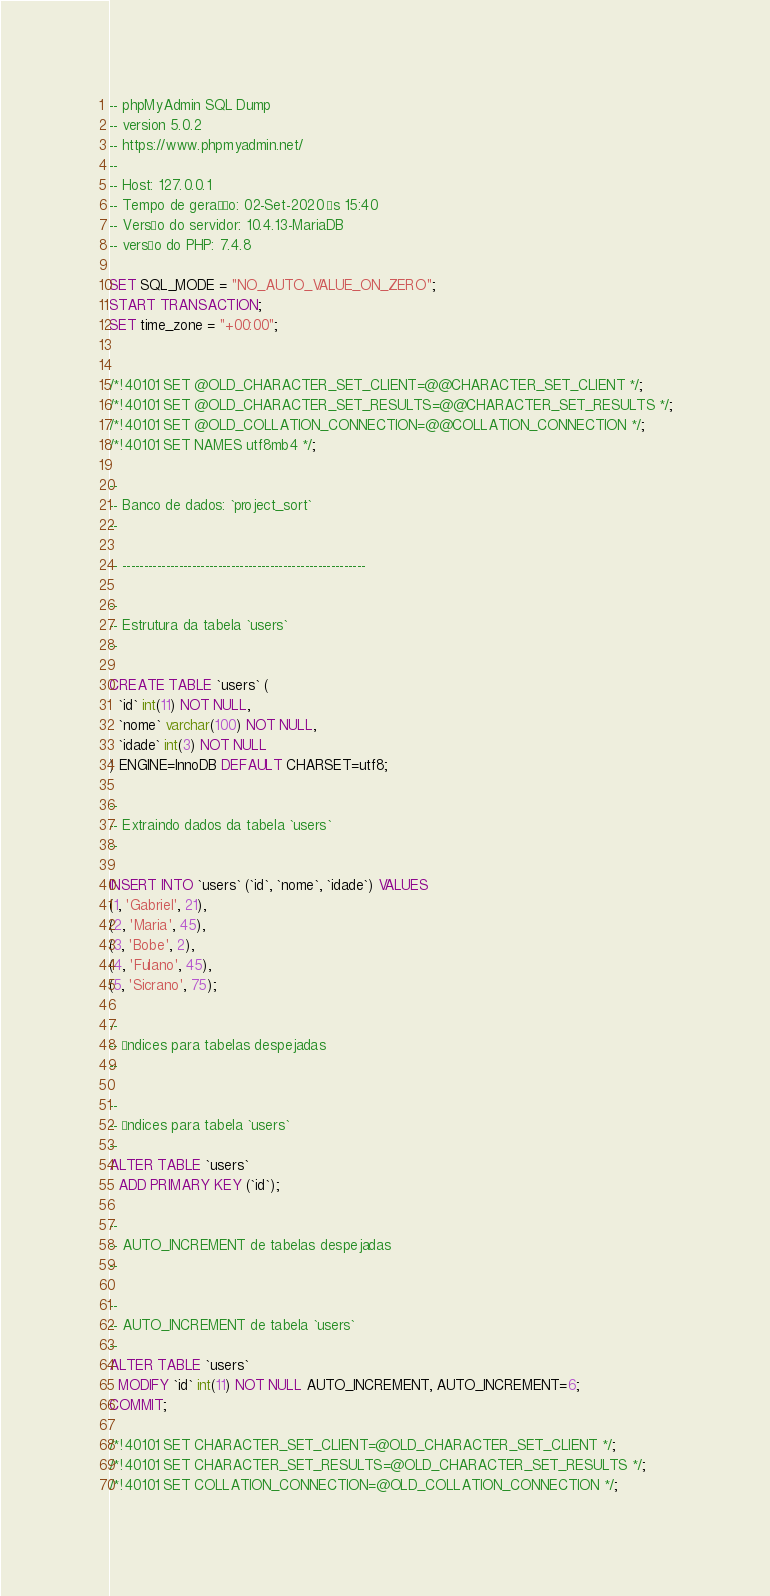Convert code to text. <code><loc_0><loc_0><loc_500><loc_500><_SQL_>-- phpMyAdmin SQL Dump
-- version 5.0.2
-- https://www.phpmyadmin.net/
--
-- Host: 127.0.0.1
-- Tempo de geração: 02-Set-2020 às 15:40
-- Versão do servidor: 10.4.13-MariaDB
-- versão do PHP: 7.4.8

SET SQL_MODE = "NO_AUTO_VALUE_ON_ZERO";
START TRANSACTION;
SET time_zone = "+00:00";


/*!40101 SET @OLD_CHARACTER_SET_CLIENT=@@CHARACTER_SET_CLIENT */;
/*!40101 SET @OLD_CHARACTER_SET_RESULTS=@@CHARACTER_SET_RESULTS */;
/*!40101 SET @OLD_COLLATION_CONNECTION=@@COLLATION_CONNECTION */;
/*!40101 SET NAMES utf8mb4 */;

--
-- Banco de dados: `project_sort`
--

-- --------------------------------------------------------

--
-- Estrutura da tabela `users`
--

CREATE TABLE `users` (
  `id` int(11) NOT NULL,
  `nome` varchar(100) NOT NULL,
  `idade` int(3) NOT NULL
) ENGINE=InnoDB DEFAULT CHARSET=utf8;

--
-- Extraindo dados da tabela `users`
--

INSERT INTO `users` (`id`, `nome`, `idade`) VALUES
(1, 'Gabriel', 21),
(2, 'Maria', 45),
(3, 'Bobe', 2),
(4, 'Fulano', 45),
(5, 'Sicrano', 75);

--
-- Índices para tabelas despejadas
--

--
-- Índices para tabela `users`
--
ALTER TABLE `users`
  ADD PRIMARY KEY (`id`);

--
-- AUTO_INCREMENT de tabelas despejadas
--

--
-- AUTO_INCREMENT de tabela `users`
--
ALTER TABLE `users`
  MODIFY `id` int(11) NOT NULL AUTO_INCREMENT, AUTO_INCREMENT=6;
COMMIT;

/*!40101 SET CHARACTER_SET_CLIENT=@OLD_CHARACTER_SET_CLIENT */;
/*!40101 SET CHARACTER_SET_RESULTS=@OLD_CHARACTER_SET_RESULTS */;
/*!40101 SET COLLATION_CONNECTION=@OLD_COLLATION_CONNECTION */;
</code> 